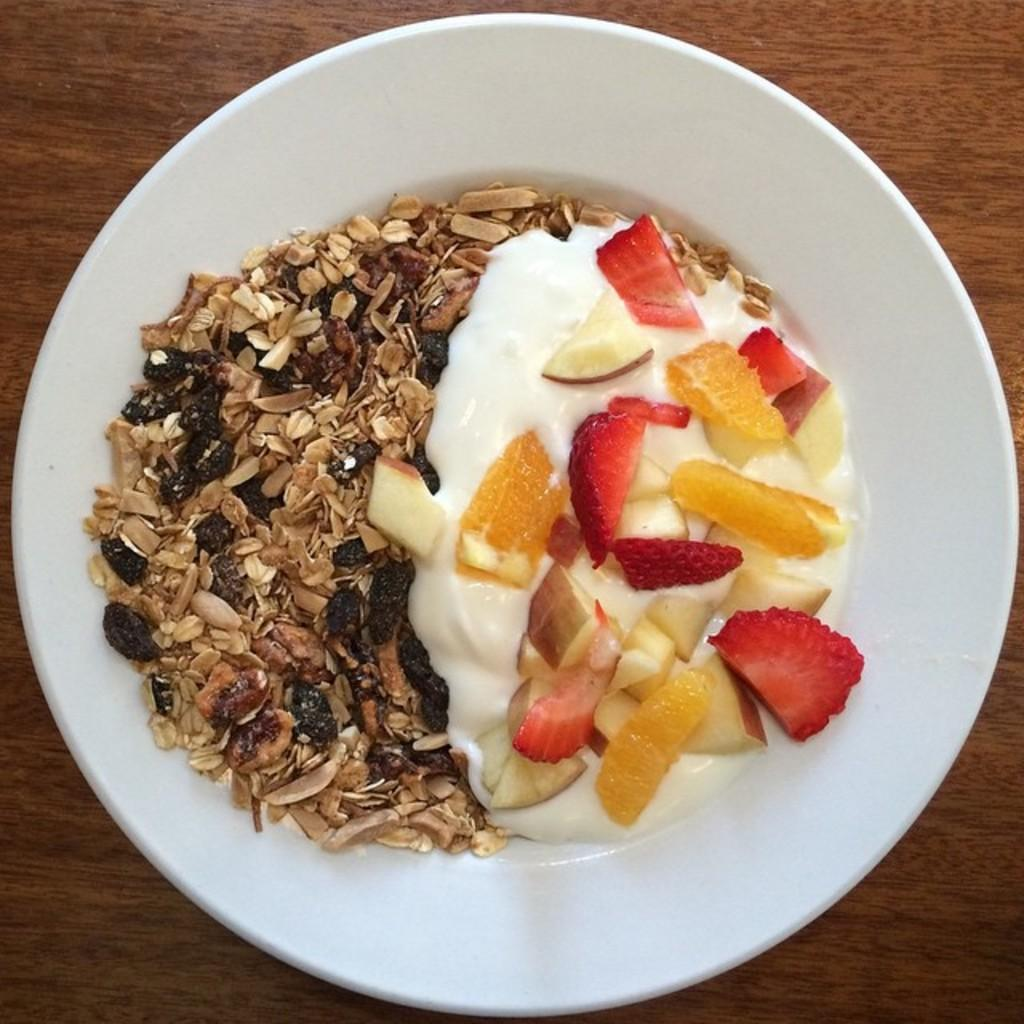What is in the bowl that is visible in the image? There is food in a bowl in the image. Can you describe any other objects or features in the image? There is a wooden object in the background of the image. What type of cheese can be seen on the zebra in the image? There is no cheese or zebra present in the image. The image only features food in a bowl and a wooden object in the background. 